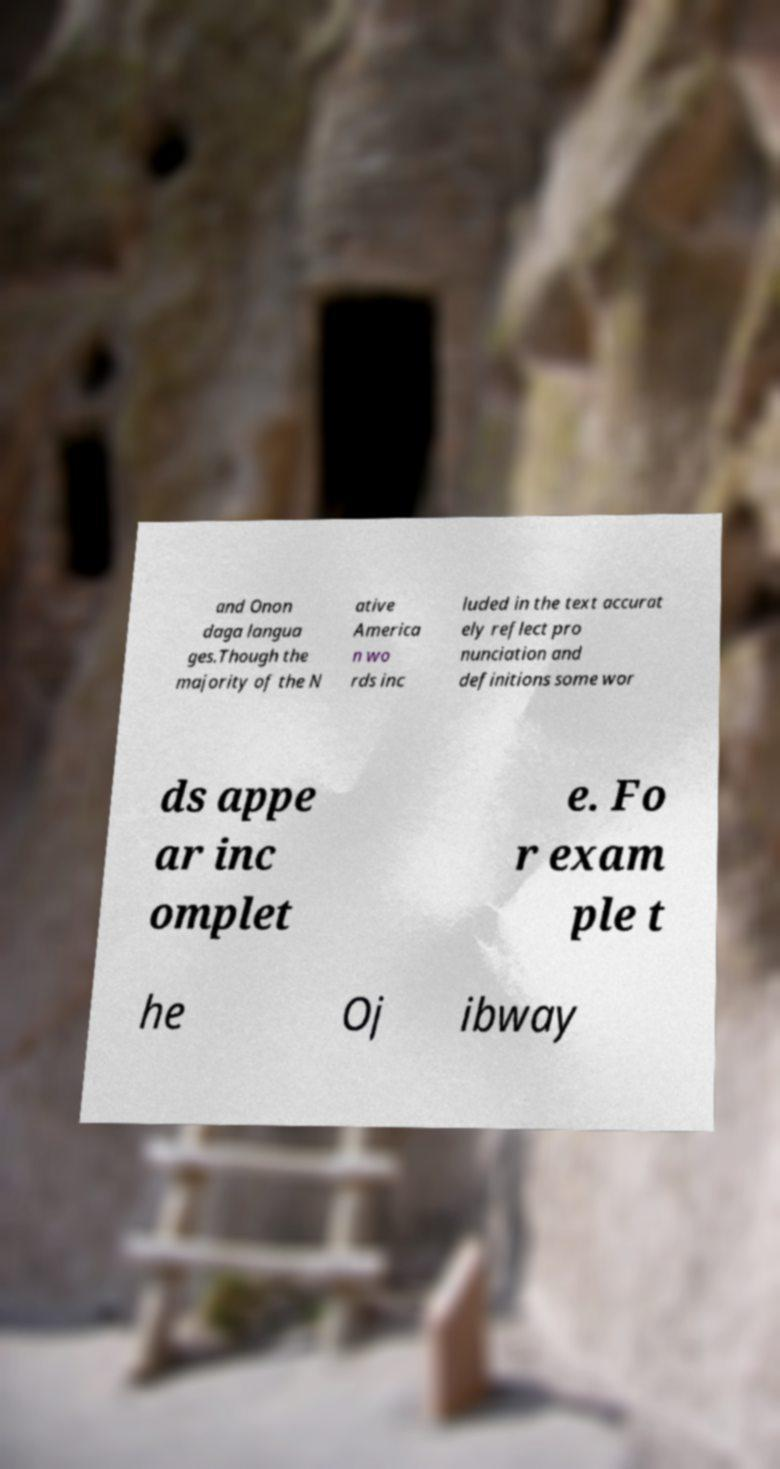Can you read and provide the text displayed in the image?This photo seems to have some interesting text. Can you extract and type it out for me? and Onon daga langua ges.Though the majority of the N ative America n wo rds inc luded in the text accurat ely reflect pro nunciation and definitions some wor ds appe ar inc omplet e. Fo r exam ple t he Oj ibway 